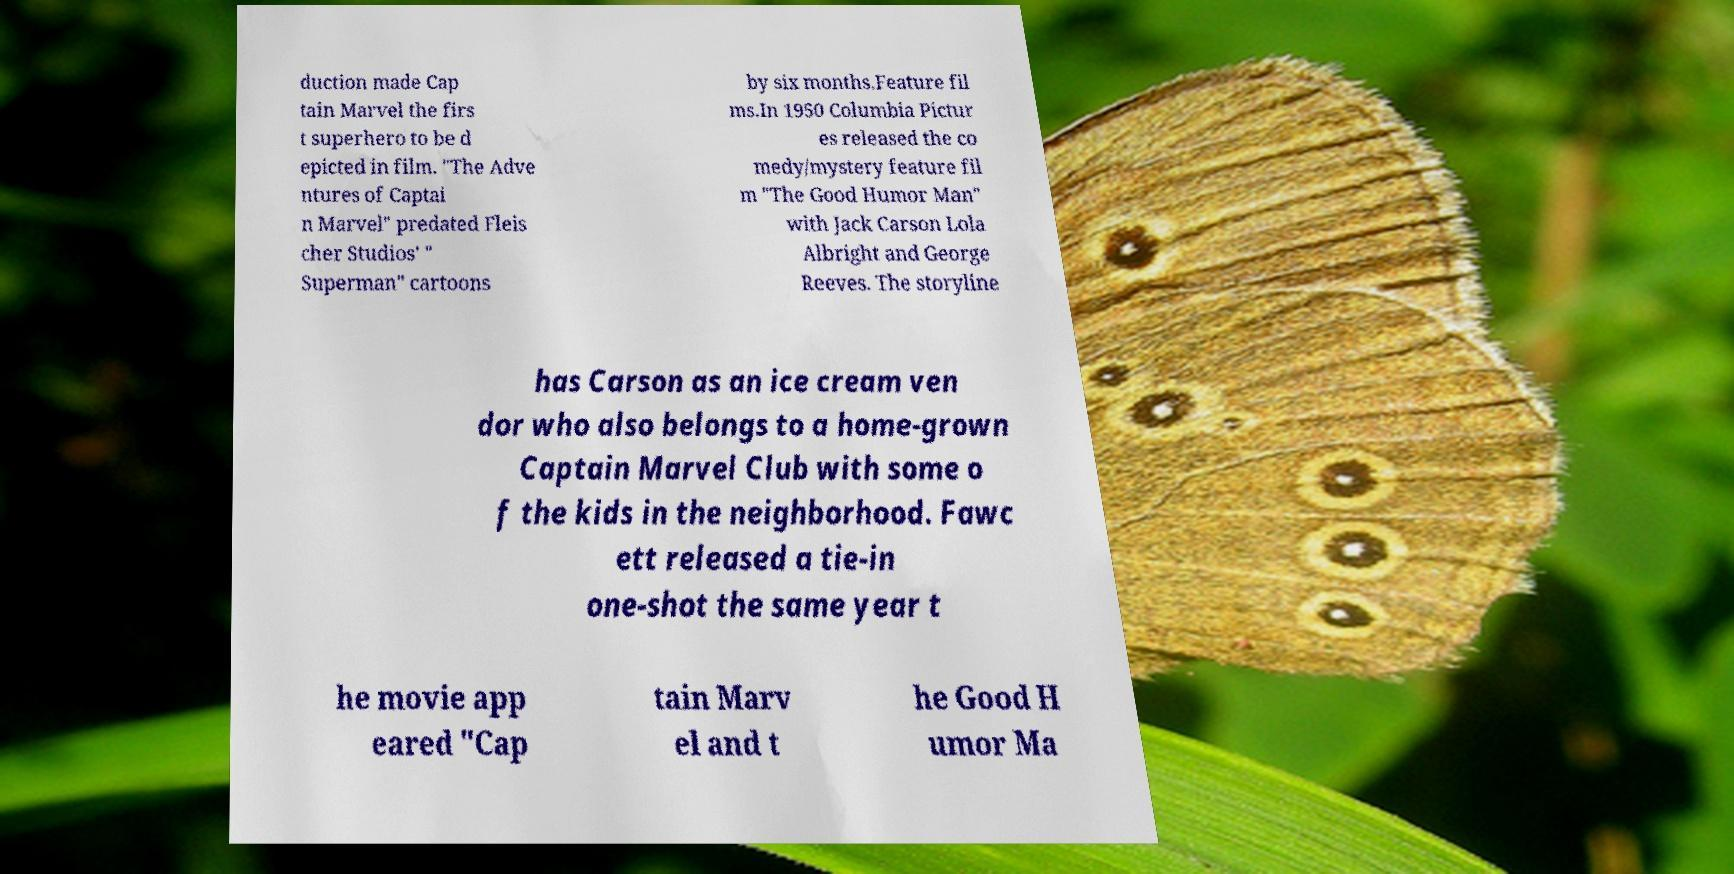What messages or text are displayed in this image? I need them in a readable, typed format. duction made Cap tain Marvel the firs t superhero to be d epicted in film. "The Adve ntures of Captai n Marvel" predated Fleis cher Studios' " Superman" cartoons by six months.Feature fil ms.In 1950 Columbia Pictur es released the co medy/mystery feature fil m "The Good Humor Man" with Jack Carson Lola Albright and George Reeves. The storyline has Carson as an ice cream ven dor who also belongs to a home-grown Captain Marvel Club with some o f the kids in the neighborhood. Fawc ett released a tie-in one-shot the same year t he movie app eared "Cap tain Marv el and t he Good H umor Ma 